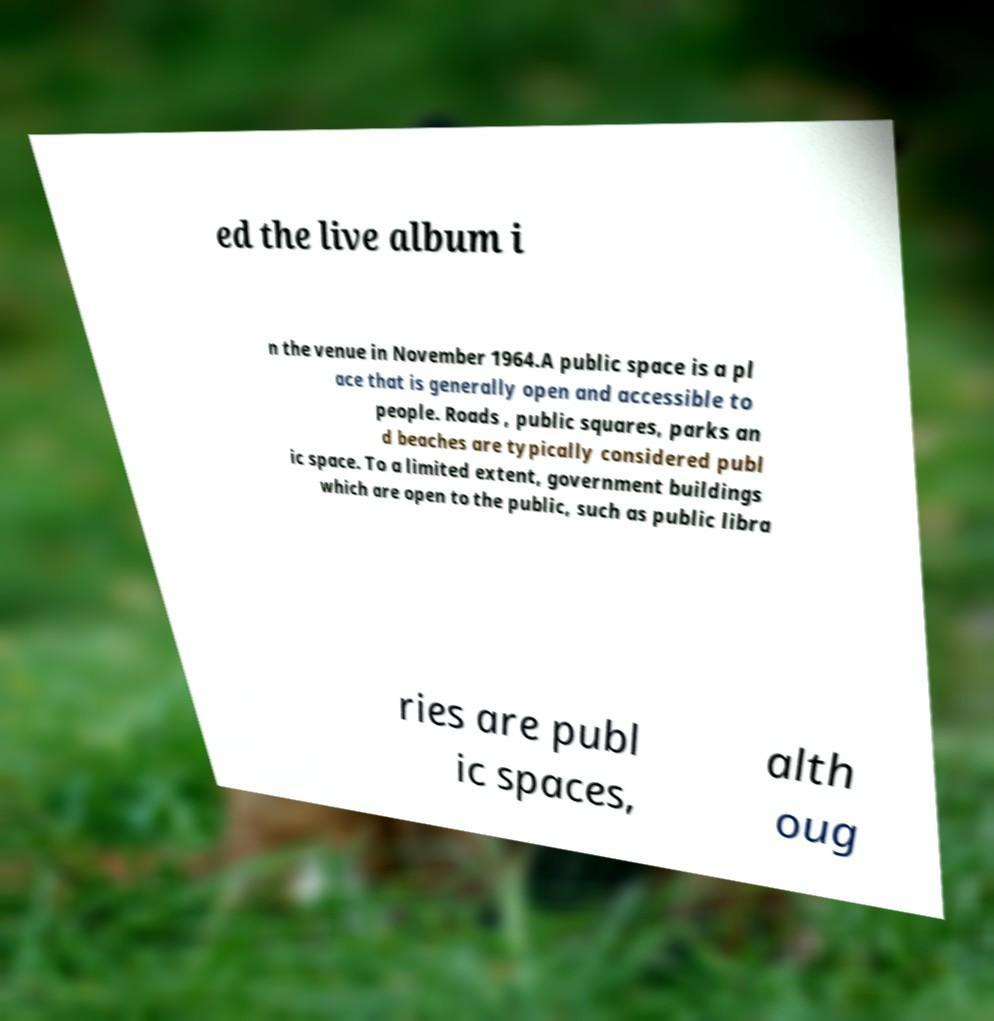Please identify and transcribe the text found in this image. ed the live album i n the venue in November 1964.A public space is a pl ace that is generally open and accessible to people. Roads , public squares, parks an d beaches are typically considered publ ic space. To a limited extent, government buildings which are open to the public, such as public libra ries are publ ic spaces, alth oug 